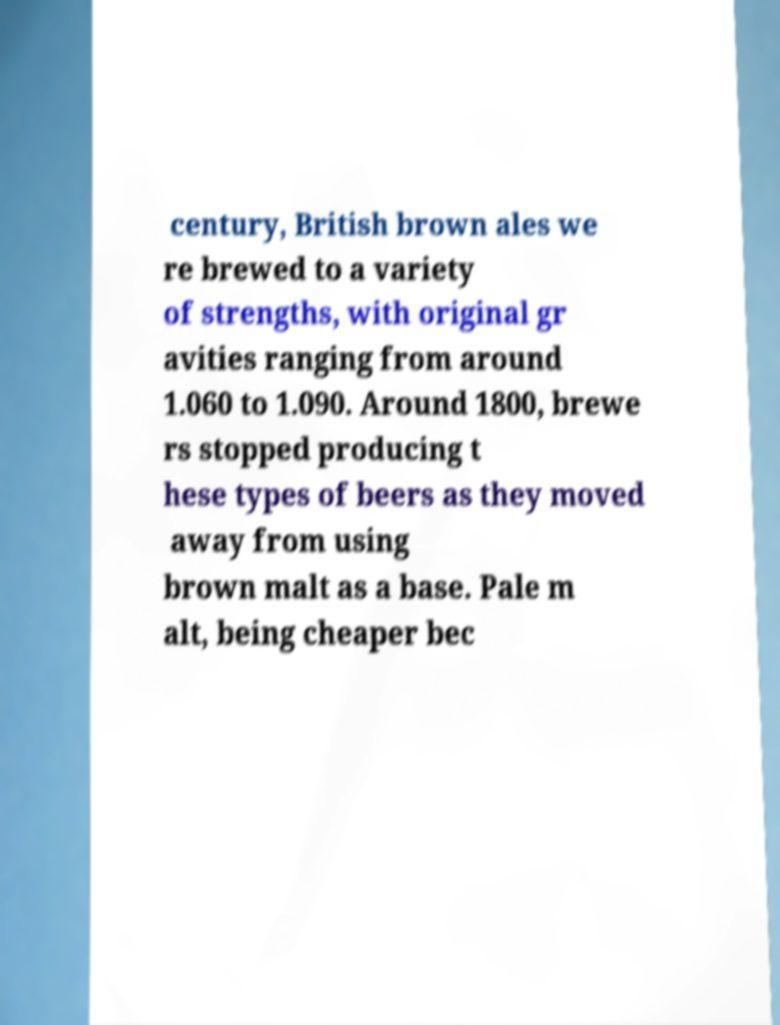Could you assist in decoding the text presented in this image and type it out clearly? century, British brown ales we re brewed to a variety of strengths, with original gr avities ranging from around 1.060 to 1.090. Around 1800, brewe rs stopped producing t hese types of beers as they moved away from using brown malt as a base. Pale m alt, being cheaper bec 